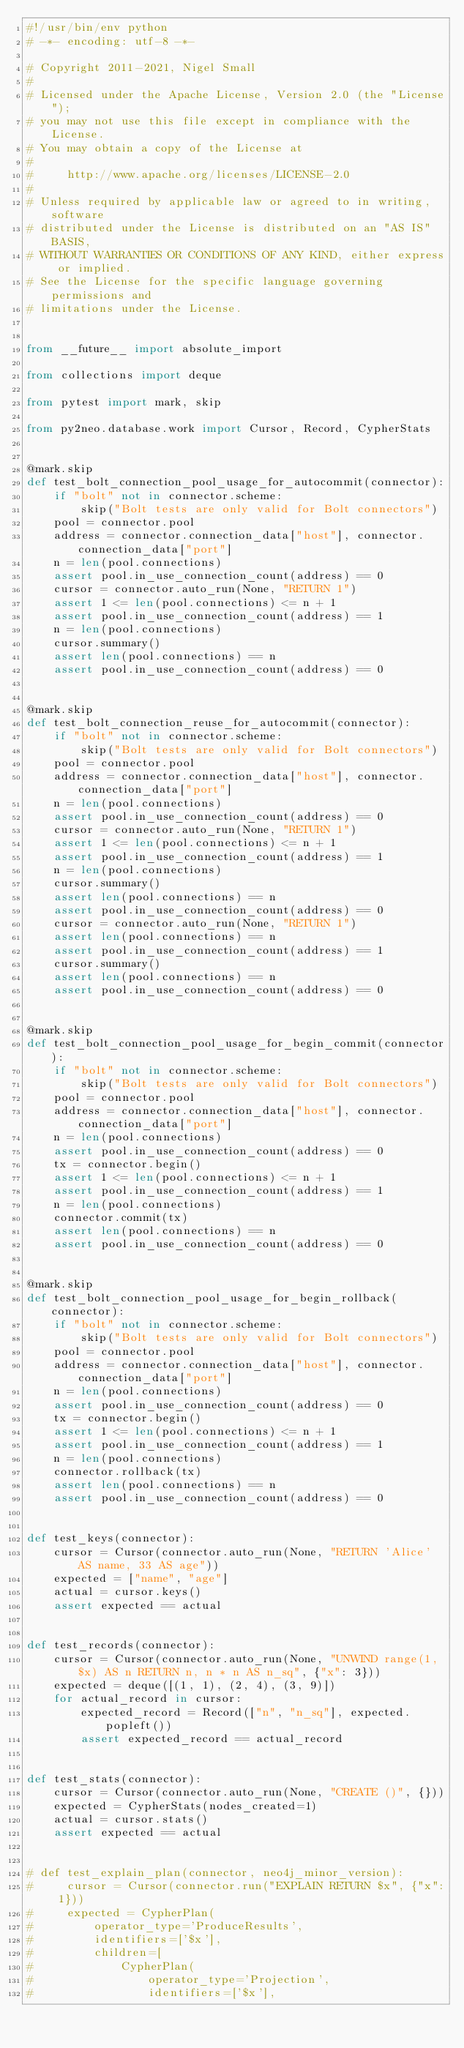Convert code to text. <code><loc_0><loc_0><loc_500><loc_500><_Python_>#!/usr/bin/env python
# -*- encoding: utf-8 -*-

# Copyright 2011-2021, Nigel Small
#
# Licensed under the Apache License, Version 2.0 (the "License");
# you may not use this file except in compliance with the License.
# You may obtain a copy of the License at
#
#     http://www.apache.org/licenses/LICENSE-2.0
#
# Unless required by applicable law or agreed to in writing, software
# distributed under the License is distributed on an "AS IS" BASIS,
# WITHOUT WARRANTIES OR CONDITIONS OF ANY KIND, either express or implied.
# See the License for the specific language governing permissions and
# limitations under the License.


from __future__ import absolute_import

from collections import deque

from pytest import mark, skip

from py2neo.database.work import Cursor, Record, CypherStats


@mark.skip
def test_bolt_connection_pool_usage_for_autocommit(connector):
    if "bolt" not in connector.scheme:
        skip("Bolt tests are only valid for Bolt connectors")
    pool = connector.pool
    address = connector.connection_data["host"], connector.connection_data["port"]
    n = len(pool.connections)
    assert pool.in_use_connection_count(address) == 0
    cursor = connector.auto_run(None, "RETURN 1")
    assert 1 <= len(pool.connections) <= n + 1
    assert pool.in_use_connection_count(address) == 1
    n = len(pool.connections)
    cursor.summary()
    assert len(pool.connections) == n
    assert pool.in_use_connection_count(address) == 0


@mark.skip
def test_bolt_connection_reuse_for_autocommit(connector):
    if "bolt" not in connector.scheme:
        skip("Bolt tests are only valid for Bolt connectors")
    pool = connector.pool
    address = connector.connection_data["host"], connector.connection_data["port"]
    n = len(pool.connections)
    assert pool.in_use_connection_count(address) == 0
    cursor = connector.auto_run(None, "RETURN 1")
    assert 1 <= len(pool.connections) <= n + 1
    assert pool.in_use_connection_count(address) == 1
    n = len(pool.connections)
    cursor.summary()
    assert len(pool.connections) == n
    assert pool.in_use_connection_count(address) == 0
    cursor = connector.auto_run(None, "RETURN 1")
    assert len(pool.connections) == n
    assert pool.in_use_connection_count(address) == 1
    cursor.summary()
    assert len(pool.connections) == n
    assert pool.in_use_connection_count(address) == 0


@mark.skip
def test_bolt_connection_pool_usage_for_begin_commit(connector):
    if "bolt" not in connector.scheme:
        skip("Bolt tests are only valid for Bolt connectors")
    pool = connector.pool
    address = connector.connection_data["host"], connector.connection_data["port"]
    n = len(pool.connections)
    assert pool.in_use_connection_count(address) == 0
    tx = connector.begin()
    assert 1 <= len(pool.connections) <= n + 1
    assert pool.in_use_connection_count(address) == 1
    n = len(pool.connections)
    connector.commit(tx)
    assert len(pool.connections) == n
    assert pool.in_use_connection_count(address) == 0


@mark.skip
def test_bolt_connection_pool_usage_for_begin_rollback(connector):
    if "bolt" not in connector.scheme:
        skip("Bolt tests are only valid for Bolt connectors")
    pool = connector.pool
    address = connector.connection_data["host"], connector.connection_data["port"]
    n = len(pool.connections)
    assert pool.in_use_connection_count(address) == 0
    tx = connector.begin()
    assert 1 <= len(pool.connections) <= n + 1
    assert pool.in_use_connection_count(address) == 1
    n = len(pool.connections)
    connector.rollback(tx)
    assert len(pool.connections) == n
    assert pool.in_use_connection_count(address) == 0


def test_keys(connector):
    cursor = Cursor(connector.auto_run(None, "RETURN 'Alice' AS name, 33 AS age"))
    expected = ["name", "age"]
    actual = cursor.keys()
    assert expected == actual


def test_records(connector):
    cursor = Cursor(connector.auto_run(None, "UNWIND range(1, $x) AS n RETURN n, n * n AS n_sq", {"x": 3}))
    expected = deque([(1, 1), (2, 4), (3, 9)])
    for actual_record in cursor:
        expected_record = Record(["n", "n_sq"], expected.popleft())
        assert expected_record == actual_record


def test_stats(connector):
    cursor = Cursor(connector.auto_run(None, "CREATE ()", {}))
    expected = CypherStats(nodes_created=1)
    actual = cursor.stats()
    assert expected == actual


# def test_explain_plan(connector, neo4j_minor_version):
#     cursor = Cursor(connector.run("EXPLAIN RETURN $x", {"x": 1}))
#     expected = CypherPlan(
#         operator_type='ProduceResults',
#         identifiers=['$x'],
#         children=[
#             CypherPlan(
#                 operator_type='Projection',
#                 identifiers=['$x'],</code> 